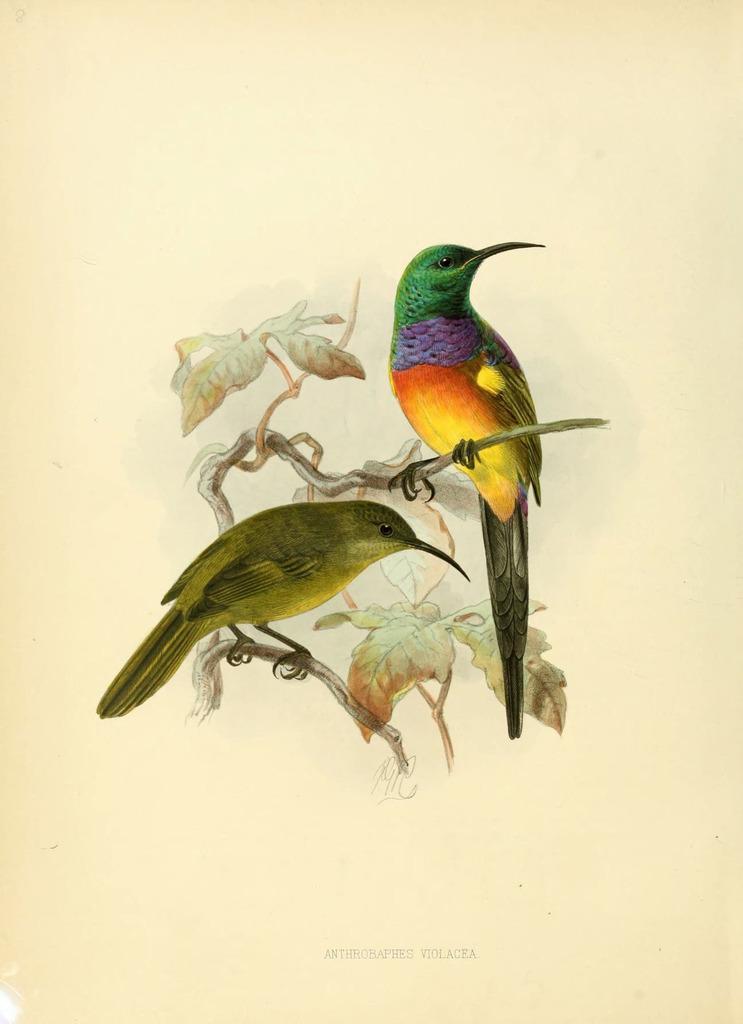How would you summarize this image in a sentence or two? In this image there is a drawing, in that drawing there are two birds standing on a branch to that branch there are leaves, at the bottom there is text. 